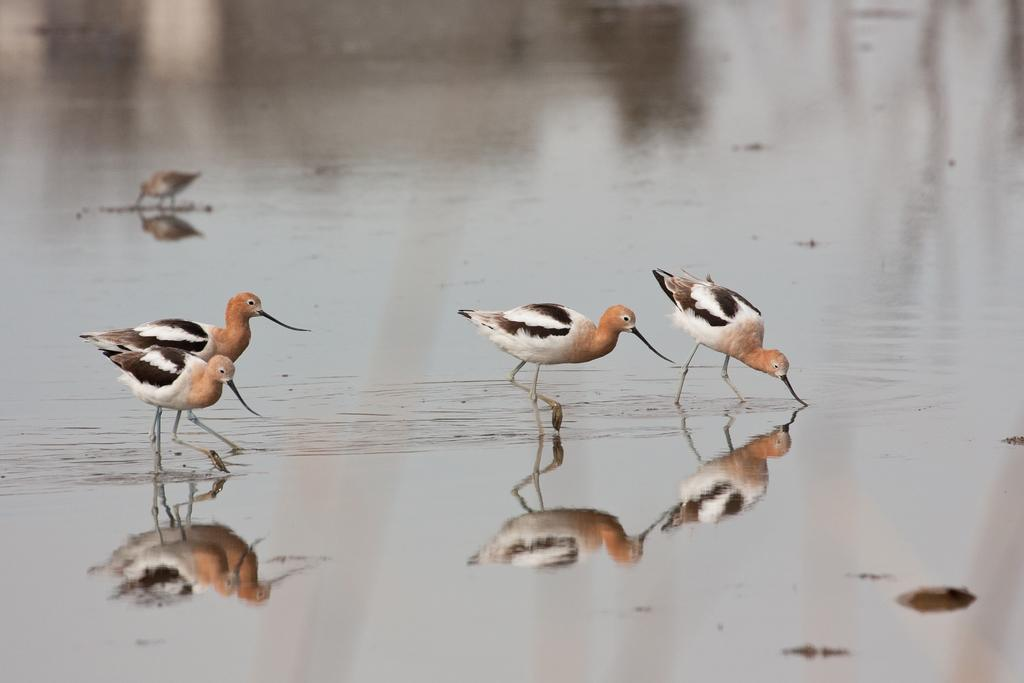What is present in the image that is not solid? There is water in the image. What type of animals can be seen in the image? There are birds in the image. Can you describe a phenomenon related to the birds and water? The reflection of the birds is visible in the water. What type of stick can be seen in the image? There is no stick present in the image. What color is the flag in the image? There is no flag present in the image. 